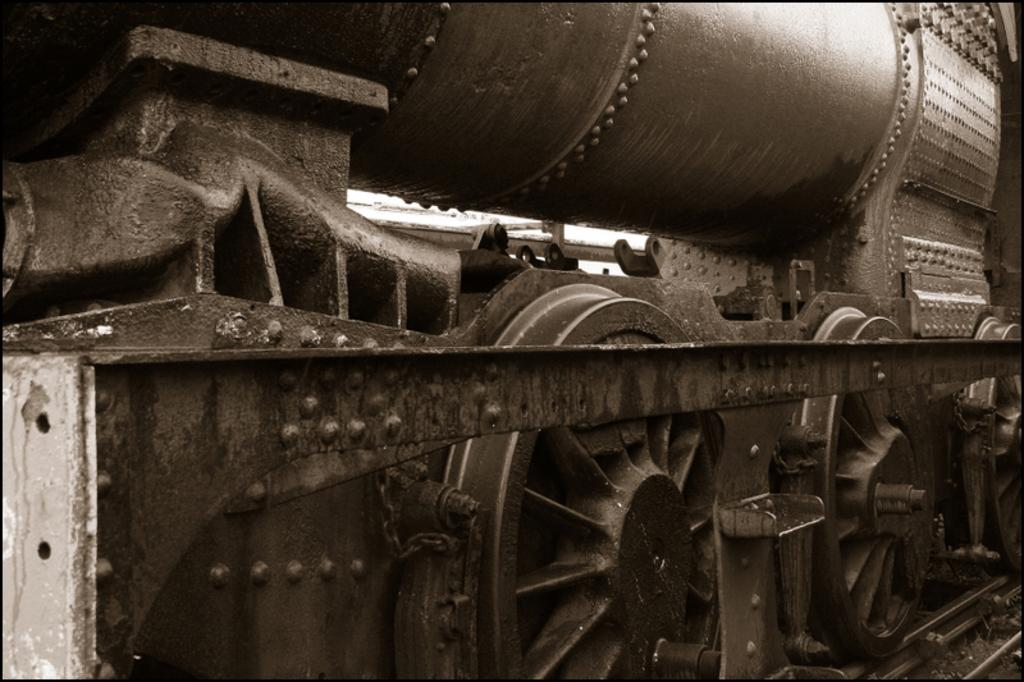What is the main subject of the picture? The main subject of the picture is a train. What can be observed about the train's wheels? The wheels of the train are moving. Where is the train located? The train is on railway tracks. What is the color of the train? The train is black in color. Can you describe the image's color scheme? The image might be in black and white. What is the name of the person taking the trip on the train in the image? There is no person or trip mentioned in the image; it only features a train with moving wheels on railway tracks. 